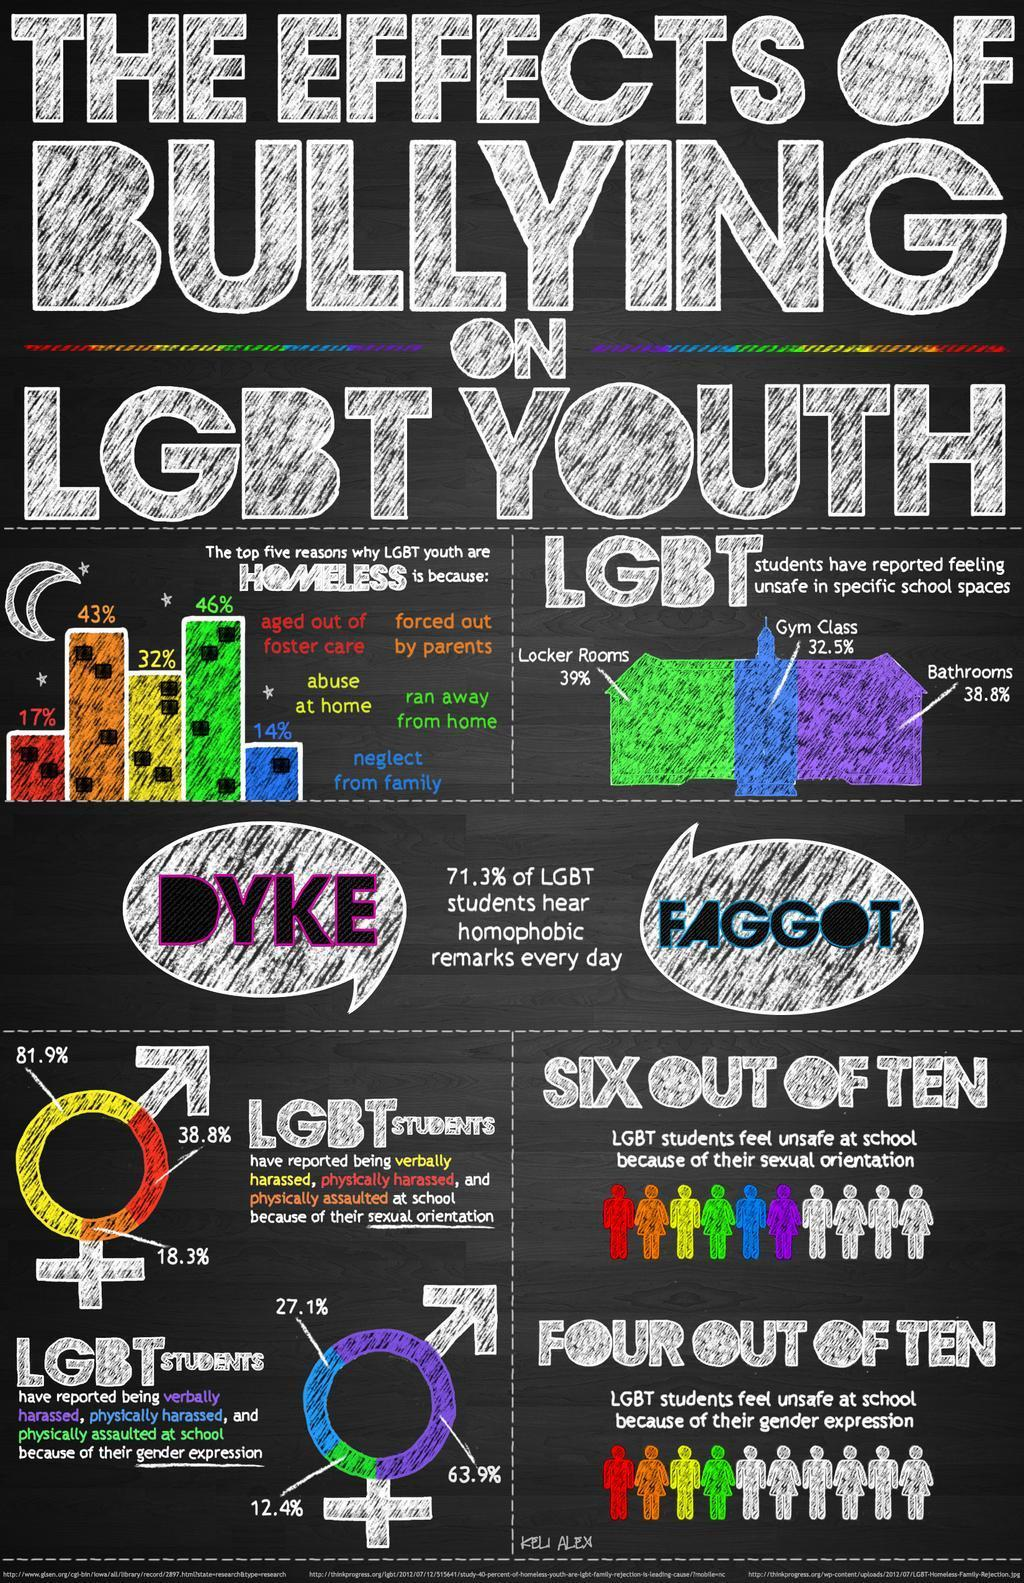What is the percentage of LGBT students who have reported feeling unsafe in gym classes in school?
Answer the question with a short phrase. 32.5% What percentage of LGBT youth are homeless because of the abuse at home? 32% What percentage of LGBT students have reported being physically harassed? 38.8% What is the percentage of LGBT students who have reported feeling unsafe in school bathrooms? 38.8% What percentage of LGBT youth are homeless as they are neglected from their families? 14% What percentage of LGBT students have reported being verbally abused? 81.9% What percentage of LGBT youth are homeless as they are forced out by their parents? 43% 